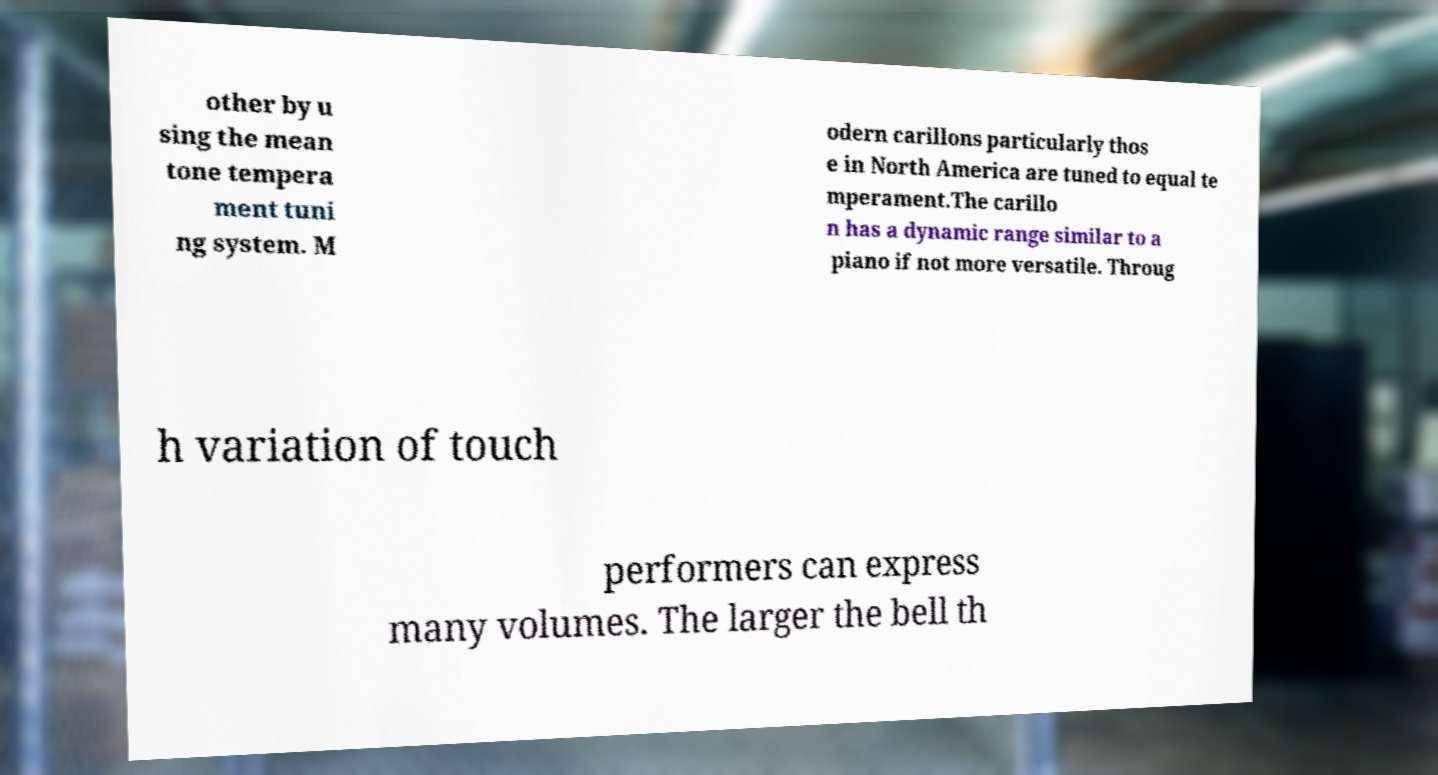Could you assist in decoding the text presented in this image and type it out clearly? other by u sing the mean tone tempera ment tuni ng system. M odern carillons particularly thos e in North America are tuned to equal te mperament.The carillo n has a dynamic range similar to a piano if not more versatile. Throug h variation of touch performers can express many volumes. The larger the bell th 